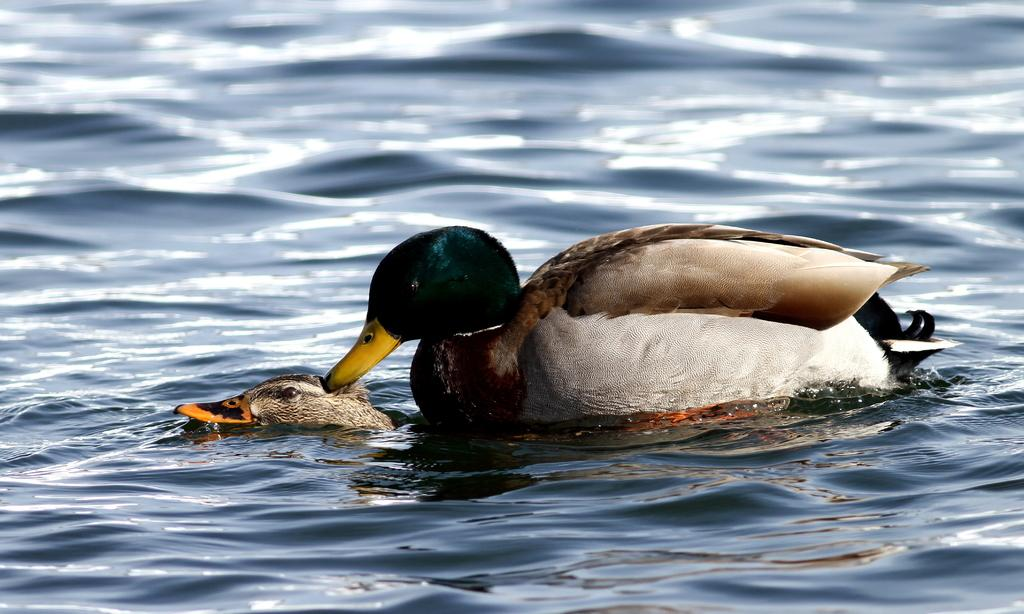What animals can be seen in the image? There are ducks in the image. What are the ducks doing in the image? The ducks are swimming in the water. What type of cake is being attacked by the ducks in the image? There is no cake present in the image, and the ducks are not attacking anything. 